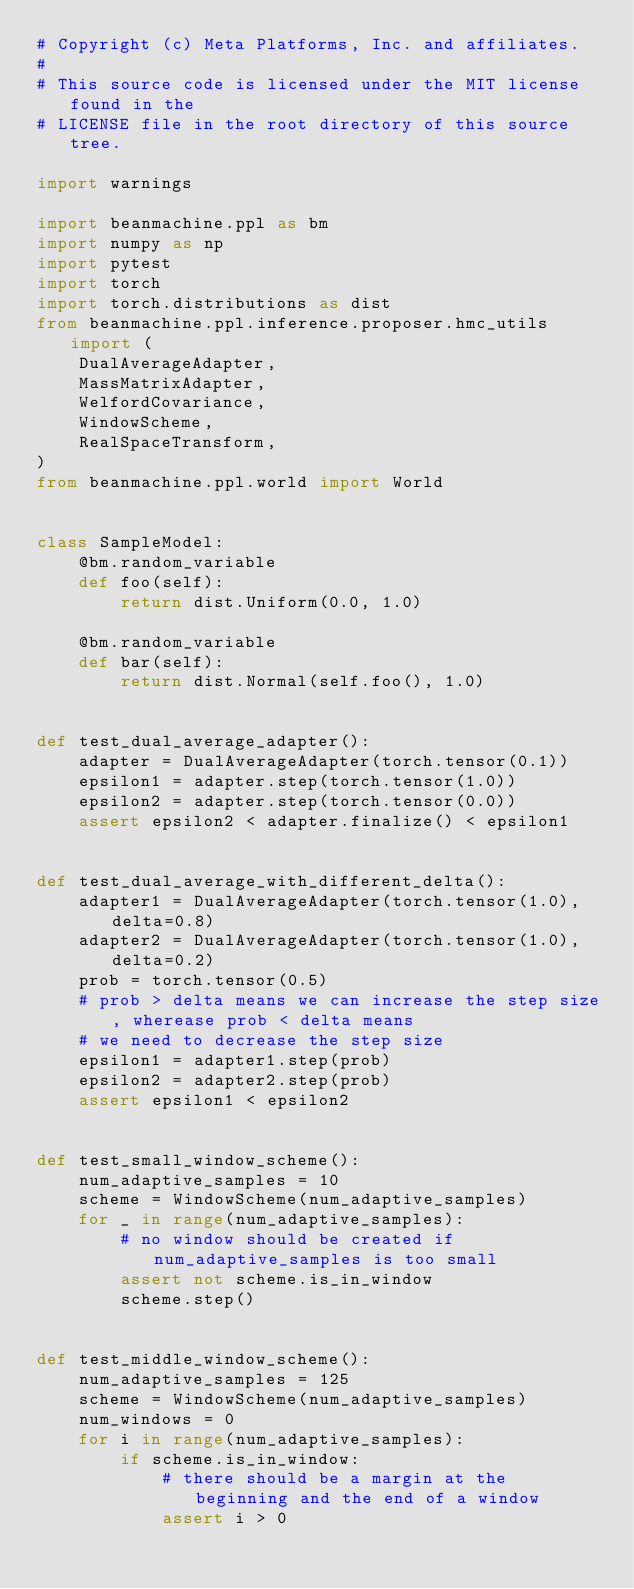<code> <loc_0><loc_0><loc_500><loc_500><_Python_># Copyright (c) Meta Platforms, Inc. and affiliates.
#
# This source code is licensed under the MIT license found in the
# LICENSE file in the root directory of this source tree.

import warnings

import beanmachine.ppl as bm
import numpy as np
import pytest
import torch
import torch.distributions as dist
from beanmachine.ppl.inference.proposer.hmc_utils import (
    DualAverageAdapter,
    MassMatrixAdapter,
    WelfordCovariance,
    WindowScheme,
    RealSpaceTransform,
)
from beanmachine.ppl.world import World


class SampleModel:
    @bm.random_variable
    def foo(self):
        return dist.Uniform(0.0, 1.0)

    @bm.random_variable
    def bar(self):
        return dist.Normal(self.foo(), 1.0)


def test_dual_average_adapter():
    adapter = DualAverageAdapter(torch.tensor(0.1))
    epsilon1 = adapter.step(torch.tensor(1.0))
    epsilon2 = adapter.step(torch.tensor(0.0))
    assert epsilon2 < adapter.finalize() < epsilon1


def test_dual_average_with_different_delta():
    adapter1 = DualAverageAdapter(torch.tensor(1.0), delta=0.8)
    adapter2 = DualAverageAdapter(torch.tensor(1.0), delta=0.2)
    prob = torch.tensor(0.5)
    # prob > delta means we can increase the step size, wherease prob < delta means
    # we need to decrease the step size
    epsilon1 = adapter1.step(prob)
    epsilon2 = adapter2.step(prob)
    assert epsilon1 < epsilon2


def test_small_window_scheme():
    num_adaptive_samples = 10
    scheme = WindowScheme(num_adaptive_samples)
    for _ in range(num_adaptive_samples):
        # no window should be created if num_adaptive_samples is too small
        assert not scheme.is_in_window
        scheme.step()


def test_middle_window_scheme():
    num_adaptive_samples = 125
    scheme = WindowScheme(num_adaptive_samples)
    num_windows = 0
    for i in range(num_adaptive_samples):
        if scheme.is_in_window:
            # there should be a margin at the beginning and the end of a window
            assert i > 0</code> 